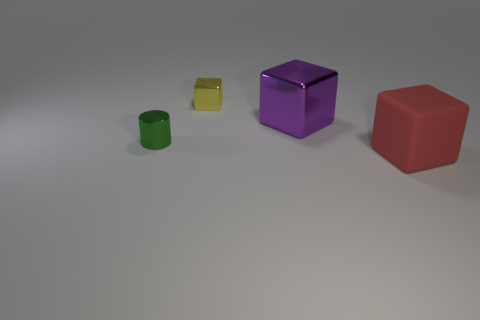Does the purple cube have the same material as the tiny green cylinder?
Your response must be concise. Yes. What number of cyan objects are either cylinders or small shiny objects?
Keep it short and to the point. 0. What number of other red matte things have the same shape as the rubber thing?
Your response must be concise. 0. What material is the large purple thing?
Offer a terse response. Metal. Is the number of purple metal objects that are behind the yellow block the same as the number of big gray rubber objects?
Keep it short and to the point. Yes. There is a thing that is the same size as the yellow block; what is its shape?
Offer a terse response. Cylinder. Is there a cube right of the shiny cube that is on the right side of the tiny metallic block?
Provide a short and direct response. Yes. What number of large things are purple metallic cubes or rubber objects?
Provide a succinct answer. 2. Is there another yellow object that has the same size as the rubber object?
Offer a very short reply. No. What number of shiny objects are yellow cubes or purple blocks?
Your answer should be very brief. 2. 